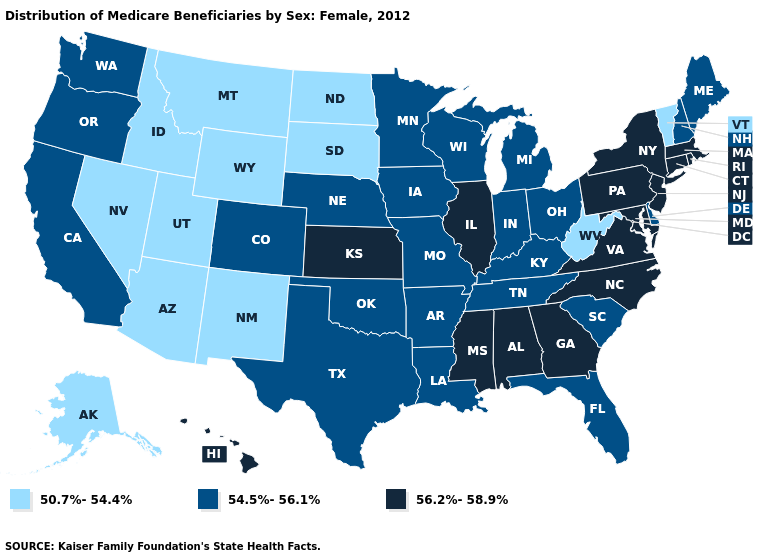Among the states that border Georgia , does Florida have the lowest value?
Write a very short answer. Yes. Name the states that have a value in the range 56.2%-58.9%?
Write a very short answer. Alabama, Connecticut, Georgia, Hawaii, Illinois, Kansas, Maryland, Massachusetts, Mississippi, New Jersey, New York, North Carolina, Pennsylvania, Rhode Island, Virginia. Name the states that have a value in the range 54.5%-56.1%?
Quick response, please. Arkansas, California, Colorado, Delaware, Florida, Indiana, Iowa, Kentucky, Louisiana, Maine, Michigan, Minnesota, Missouri, Nebraska, New Hampshire, Ohio, Oklahoma, Oregon, South Carolina, Tennessee, Texas, Washington, Wisconsin. What is the value of Ohio?
Concise answer only. 54.5%-56.1%. Does New Hampshire have the same value as Idaho?
Write a very short answer. No. Name the states that have a value in the range 54.5%-56.1%?
Concise answer only. Arkansas, California, Colorado, Delaware, Florida, Indiana, Iowa, Kentucky, Louisiana, Maine, Michigan, Minnesota, Missouri, Nebraska, New Hampshire, Ohio, Oklahoma, Oregon, South Carolina, Tennessee, Texas, Washington, Wisconsin. What is the value of Louisiana?
Quick response, please. 54.5%-56.1%. Does Ohio have the highest value in the USA?
Write a very short answer. No. How many symbols are there in the legend?
Be succinct. 3. What is the value of Massachusetts?
Quick response, please. 56.2%-58.9%. What is the value of Alabama?
Concise answer only. 56.2%-58.9%. Does Texas have the lowest value in the South?
Answer briefly. No. What is the lowest value in the South?
Keep it brief. 50.7%-54.4%. Which states have the lowest value in the USA?
Concise answer only. Alaska, Arizona, Idaho, Montana, Nevada, New Mexico, North Dakota, South Dakota, Utah, Vermont, West Virginia, Wyoming. Does Hawaii have a lower value than Virginia?
Answer briefly. No. 